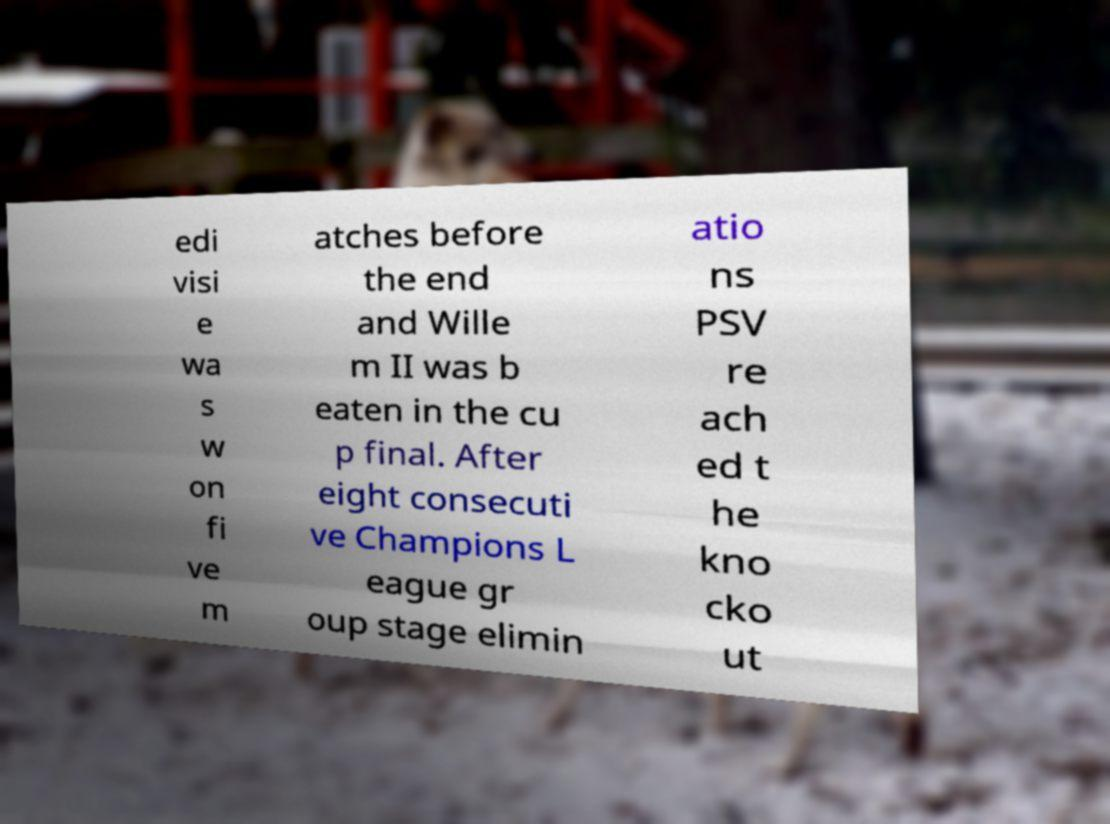Please read and relay the text visible in this image. What does it say? edi visi e wa s w on fi ve m atches before the end and Wille m II was b eaten in the cu p final. After eight consecuti ve Champions L eague gr oup stage elimin atio ns PSV re ach ed t he kno cko ut 